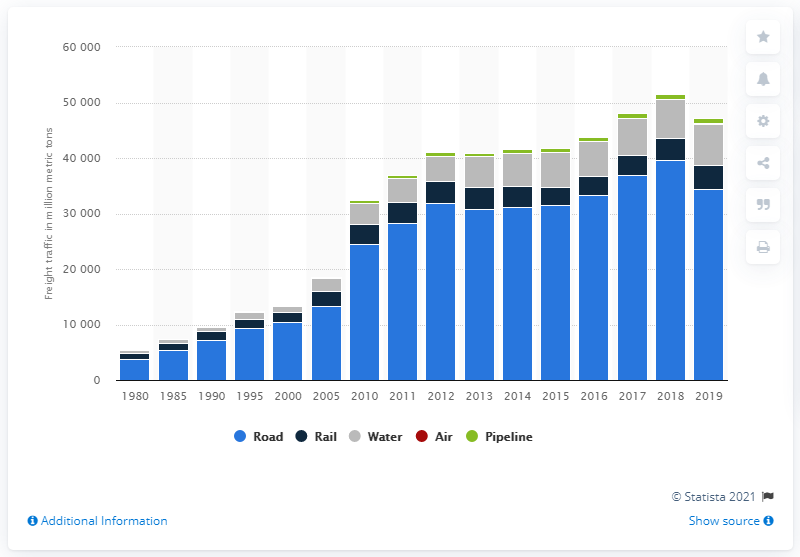Outline some significant characteristics in this image. In 2019, air freight in China totaled 7.53 million metric tons, indicating a significant increase from the previous year. 